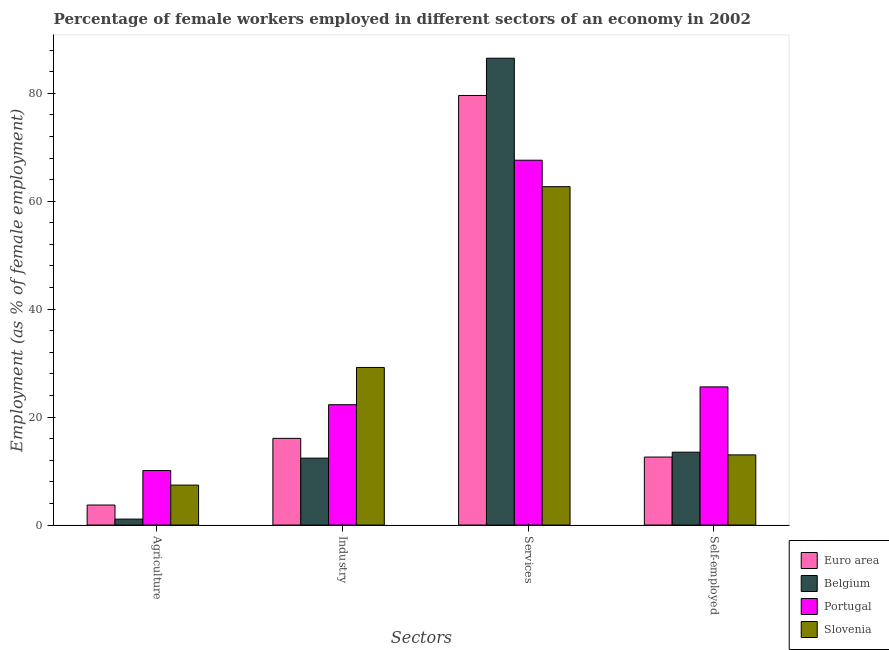How many groups of bars are there?
Keep it short and to the point. 4. What is the label of the 2nd group of bars from the left?
Provide a succinct answer. Industry. What is the percentage of female workers in agriculture in Belgium?
Give a very brief answer. 1.1. Across all countries, what is the maximum percentage of female workers in agriculture?
Your answer should be compact. 10.1. Across all countries, what is the minimum percentage of female workers in agriculture?
Your answer should be compact. 1.1. In which country was the percentage of female workers in industry maximum?
Your response must be concise. Slovenia. In which country was the percentage of female workers in services minimum?
Make the answer very short. Slovenia. What is the total percentage of female workers in services in the graph?
Offer a terse response. 296.4. What is the difference between the percentage of female workers in industry in Euro area and that in Slovenia?
Provide a short and direct response. -13.14. What is the difference between the percentage of female workers in agriculture in Portugal and the percentage of self employed female workers in Belgium?
Your response must be concise. -3.4. What is the average percentage of self employed female workers per country?
Make the answer very short. 16.17. What is the difference between the percentage of self employed female workers and percentage of female workers in industry in Belgium?
Keep it short and to the point. 1.1. In how many countries, is the percentage of female workers in agriculture greater than 44 %?
Keep it short and to the point. 0. What is the ratio of the percentage of self employed female workers in Euro area to that in Portugal?
Make the answer very short. 0.49. Is the percentage of female workers in agriculture in Slovenia less than that in Portugal?
Offer a very short reply. Yes. What is the difference between the highest and the second highest percentage of self employed female workers?
Give a very brief answer. 12.1. What is the difference between the highest and the lowest percentage of female workers in industry?
Give a very brief answer. 16.8. In how many countries, is the percentage of female workers in services greater than the average percentage of female workers in services taken over all countries?
Your answer should be compact. 2. Is the sum of the percentage of female workers in industry in Portugal and Euro area greater than the maximum percentage of female workers in agriculture across all countries?
Keep it short and to the point. Yes. Is it the case that in every country, the sum of the percentage of female workers in services and percentage of female workers in agriculture is greater than the sum of percentage of self employed female workers and percentage of female workers in industry?
Ensure brevity in your answer.  Yes. What does the 3rd bar from the right in Agriculture represents?
Give a very brief answer. Belgium. How many bars are there?
Provide a succinct answer. 16. Are all the bars in the graph horizontal?
Provide a succinct answer. No. What is the difference between two consecutive major ticks on the Y-axis?
Provide a succinct answer. 20. Are the values on the major ticks of Y-axis written in scientific E-notation?
Provide a succinct answer. No. Where does the legend appear in the graph?
Offer a terse response. Bottom right. How are the legend labels stacked?
Your response must be concise. Vertical. What is the title of the graph?
Your response must be concise. Percentage of female workers employed in different sectors of an economy in 2002. What is the label or title of the X-axis?
Ensure brevity in your answer.  Sectors. What is the label or title of the Y-axis?
Offer a very short reply. Employment (as % of female employment). What is the Employment (as % of female employment) in Euro area in Agriculture?
Make the answer very short. 3.71. What is the Employment (as % of female employment) of Belgium in Agriculture?
Your answer should be very brief. 1.1. What is the Employment (as % of female employment) in Portugal in Agriculture?
Keep it short and to the point. 10.1. What is the Employment (as % of female employment) in Slovenia in Agriculture?
Your answer should be very brief. 7.4. What is the Employment (as % of female employment) in Euro area in Industry?
Make the answer very short. 16.06. What is the Employment (as % of female employment) of Belgium in Industry?
Ensure brevity in your answer.  12.4. What is the Employment (as % of female employment) of Portugal in Industry?
Your answer should be compact. 22.3. What is the Employment (as % of female employment) of Slovenia in Industry?
Make the answer very short. 29.2. What is the Employment (as % of female employment) in Euro area in Services?
Provide a succinct answer. 79.6. What is the Employment (as % of female employment) in Belgium in Services?
Provide a succinct answer. 86.5. What is the Employment (as % of female employment) of Portugal in Services?
Provide a succinct answer. 67.6. What is the Employment (as % of female employment) of Slovenia in Services?
Offer a terse response. 62.7. What is the Employment (as % of female employment) of Euro area in Self-employed?
Provide a short and direct response. 12.6. What is the Employment (as % of female employment) of Portugal in Self-employed?
Offer a terse response. 25.6. What is the Employment (as % of female employment) in Slovenia in Self-employed?
Provide a short and direct response. 13. Across all Sectors, what is the maximum Employment (as % of female employment) of Euro area?
Offer a very short reply. 79.6. Across all Sectors, what is the maximum Employment (as % of female employment) in Belgium?
Provide a short and direct response. 86.5. Across all Sectors, what is the maximum Employment (as % of female employment) in Portugal?
Offer a terse response. 67.6. Across all Sectors, what is the maximum Employment (as % of female employment) of Slovenia?
Your answer should be compact. 62.7. Across all Sectors, what is the minimum Employment (as % of female employment) in Euro area?
Give a very brief answer. 3.71. Across all Sectors, what is the minimum Employment (as % of female employment) in Belgium?
Keep it short and to the point. 1.1. Across all Sectors, what is the minimum Employment (as % of female employment) in Portugal?
Ensure brevity in your answer.  10.1. Across all Sectors, what is the minimum Employment (as % of female employment) in Slovenia?
Your response must be concise. 7.4. What is the total Employment (as % of female employment) of Euro area in the graph?
Offer a terse response. 111.96. What is the total Employment (as % of female employment) in Belgium in the graph?
Give a very brief answer. 113.5. What is the total Employment (as % of female employment) in Portugal in the graph?
Ensure brevity in your answer.  125.6. What is the total Employment (as % of female employment) in Slovenia in the graph?
Your answer should be compact. 112.3. What is the difference between the Employment (as % of female employment) of Euro area in Agriculture and that in Industry?
Your answer should be compact. -12.35. What is the difference between the Employment (as % of female employment) of Belgium in Agriculture and that in Industry?
Provide a short and direct response. -11.3. What is the difference between the Employment (as % of female employment) in Slovenia in Agriculture and that in Industry?
Provide a succinct answer. -21.8. What is the difference between the Employment (as % of female employment) of Euro area in Agriculture and that in Services?
Ensure brevity in your answer.  -75.89. What is the difference between the Employment (as % of female employment) in Belgium in Agriculture and that in Services?
Give a very brief answer. -85.4. What is the difference between the Employment (as % of female employment) of Portugal in Agriculture and that in Services?
Provide a succinct answer. -57.5. What is the difference between the Employment (as % of female employment) of Slovenia in Agriculture and that in Services?
Offer a very short reply. -55.3. What is the difference between the Employment (as % of female employment) of Euro area in Agriculture and that in Self-employed?
Ensure brevity in your answer.  -8.89. What is the difference between the Employment (as % of female employment) in Belgium in Agriculture and that in Self-employed?
Keep it short and to the point. -12.4. What is the difference between the Employment (as % of female employment) of Portugal in Agriculture and that in Self-employed?
Keep it short and to the point. -15.5. What is the difference between the Employment (as % of female employment) of Slovenia in Agriculture and that in Self-employed?
Give a very brief answer. -5.6. What is the difference between the Employment (as % of female employment) in Euro area in Industry and that in Services?
Your answer should be very brief. -63.53. What is the difference between the Employment (as % of female employment) in Belgium in Industry and that in Services?
Offer a terse response. -74.1. What is the difference between the Employment (as % of female employment) of Portugal in Industry and that in Services?
Offer a terse response. -45.3. What is the difference between the Employment (as % of female employment) of Slovenia in Industry and that in Services?
Provide a short and direct response. -33.5. What is the difference between the Employment (as % of female employment) of Euro area in Industry and that in Self-employed?
Provide a succinct answer. 3.46. What is the difference between the Employment (as % of female employment) in Belgium in Industry and that in Self-employed?
Your answer should be compact. -1.1. What is the difference between the Employment (as % of female employment) of Portugal in Industry and that in Self-employed?
Your response must be concise. -3.3. What is the difference between the Employment (as % of female employment) in Euro area in Services and that in Self-employed?
Provide a succinct answer. 67. What is the difference between the Employment (as % of female employment) in Belgium in Services and that in Self-employed?
Your answer should be compact. 73. What is the difference between the Employment (as % of female employment) of Slovenia in Services and that in Self-employed?
Offer a terse response. 49.7. What is the difference between the Employment (as % of female employment) of Euro area in Agriculture and the Employment (as % of female employment) of Belgium in Industry?
Your answer should be compact. -8.69. What is the difference between the Employment (as % of female employment) in Euro area in Agriculture and the Employment (as % of female employment) in Portugal in Industry?
Give a very brief answer. -18.59. What is the difference between the Employment (as % of female employment) of Euro area in Agriculture and the Employment (as % of female employment) of Slovenia in Industry?
Keep it short and to the point. -25.49. What is the difference between the Employment (as % of female employment) in Belgium in Agriculture and the Employment (as % of female employment) in Portugal in Industry?
Your answer should be compact. -21.2. What is the difference between the Employment (as % of female employment) of Belgium in Agriculture and the Employment (as % of female employment) of Slovenia in Industry?
Provide a short and direct response. -28.1. What is the difference between the Employment (as % of female employment) in Portugal in Agriculture and the Employment (as % of female employment) in Slovenia in Industry?
Your response must be concise. -19.1. What is the difference between the Employment (as % of female employment) in Euro area in Agriculture and the Employment (as % of female employment) in Belgium in Services?
Offer a very short reply. -82.79. What is the difference between the Employment (as % of female employment) in Euro area in Agriculture and the Employment (as % of female employment) in Portugal in Services?
Your answer should be very brief. -63.89. What is the difference between the Employment (as % of female employment) in Euro area in Agriculture and the Employment (as % of female employment) in Slovenia in Services?
Your answer should be compact. -58.99. What is the difference between the Employment (as % of female employment) in Belgium in Agriculture and the Employment (as % of female employment) in Portugal in Services?
Offer a terse response. -66.5. What is the difference between the Employment (as % of female employment) in Belgium in Agriculture and the Employment (as % of female employment) in Slovenia in Services?
Offer a terse response. -61.6. What is the difference between the Employment (as % of female employment) of Portugal in Agriculture and the Employment (as % of female employment) of Slovenia in Services?
Your response must be concise. -52.6. What is the difference between the Employment (as % of female employment) in Euro area in Agriculture and the Employment (as % of female employment) in Belgium in Self-employed?
Make the answer very short. -9.79. What is the difference between the Employment (as % of female employment) of Euro area in Agriculture and the Employment (as % of female employment) of Portugal in Self-employed?
Give a very brief answer. -21.89. What is the difference between the Employment (as % of female employment) of Euro area in Agriculture and the Employment (as % of female employment) of Slovenia in Self-employed?
Make the answer very short. -9.29. What is the difference between the Employment (as % of female employment) of Belgium in Agriculture and the Employment (as % of female employment) of Portugal in Self-employed?
Give a very brief answer. -24.5. What is the difference between the Employment (as % of female employment) of Euro area in Industry and the Employment (as % of female employment) of Belgium in Services?
Your answer should be very brief. -70.44. What is the difference between the Employment (as % of female employment) of Euro area in Industry and the Employment (as % of female employment) of Portugal in Services?
Offer a terse response. -51.54. What is the difference between the Employment (as % of female employment) of Euro area in Industry and the Employment (as % of female employment) of Slovenia in Services?
Give a very brief answer. -46.64. What is the difference between the Employment (as % of female employment) of Belgium in Industry and the Employment (as % of female employment) of Portugal in Services?
Provide a succinct answer. -55.2. What is the difference between the Employment (as % of female employment) in Belgium in Industry and the Employment (as % of female employment) in Slovenia in Services?
Your answer should be compact. -50.3. What is the difference between the Employment (as % of female employment) of Portugal in Industry and the Employment (as % of female employment) of Slovenia in Services?
Provide a succinct answer. -40.4. What is the difference between the Employment (as % of female employment) in Euro area in Industry and the Employment (as % of female employment) in Belgium in Self-employed?
Ensure brevity in your answer.  2.56. What is the difference between the Employment (as % of female employment) in Euro area in Industry and the Employment (as % of female employment) in Portugal in Self-employed?
Your answer should be very brief. -9.54. What is the difference between the Employment (as % of female employment) of Euro area in Industry and the Employment (as % of female employment) of Slovenia in Self-employed?
Make the answer very short. 3.06. What is the difference between the Employment (as % of female employment) in Euro area in Services and the Employment (as % of female employment) in Belgium in Self-employed?
Keep it short and to the point. 66.1. What is the difference between the Employment (as % of female employment) in Euro area in Services and the Employment (as % of female employment) in Portugal in Self-employed?
Keep it short and to the point. 54. What is the difference between the Employment (as % of female employment) in Euro area in Services and the Employment (as % of female employment) in Slovenia in Self-employed?
Your answer should be compact. 66.6. What is the difference between the Employment (as % of female employment) in Belgium in Services and the Employment (as % of female employment) in Portugal in Self-employed?
Give a very brief answer. 60.9. What is the difference between the Employment (as % of female employment) in Belgium in Services and the Employment (as % of female employment) in Slovenia in Self-employed?
Offer a terse response. 73.5. What is the difference between the Employment (as % of female employment) in Portugal in Services and the Employment (as % of female employment) in Slovenia in Self-employed?
Provide a succinct answer. 54.6. What is the average Employment (as % of female employment) of Euro area per Sectors?
Keep it short and to the point. 27.99. What is the average Employment (as % of female employment) in Belgium per Sectors?
Make the answer very short. 28.38. What is the average Employment (as % of female employment) in Portugal per Sectors?
Give a very brief answer. 31.4. What is the average Employment (as % of female employment) in Slovenia per Sectors?
Your answer should be very brief. 28.07. What is the difference between the Employment (as % of female employment) in Euro area and Employment (as % of female employment) in Belgium in Agriculture?
Provide a succinct answer. 2.61. What is the difference between the Employment (as % of female employment) of Euro area and Employment (as % of female employment) of Portugal in Agriculture?
Offer a very short reply. -6.39. What is the difference between the Employment (as % of female employment) in Euro area and Employment (as % of female employment) in Slovenia in Agriculture?
Make the answer very short. -3.69. What is the difference between the Employment (as % of female employment) of Belgium and Employment (as % of female employment) of Portugal in Agriculture?
Provide a succinct answer. -9. What is the difference between the Employment (as % of female employment) of Portugal and Employment (as % of female employment) of Slovenia in Agriculture?
Provide a succinct answer. 2.7. What is the difference between the Employment (as % of female employment) in Euro area and Employment (as % of female employment) in Belgium in Industry?
Your answer should be very brief. 3.66. What is the difference between the Employment (as % of female employment) in Euro area and Employment (as % of female employment) in Portugal in Industry?
Provide a succinct answer. -6.24. What is the difference between the Employment (as % of female employment) of Euro area and Employment (as % of female employment) of Slovenia in Industry?
Give a very brief answer. -13.14. What is the difference between the Employment (as % of female employment) of Belgium and Employment (as % of female employment) of Portugal in Industry?
Make the answer very short. -9.9. What is the difference between the Employment (as % of female employment) in Belgium and Employment (as % of female employment) in Slovenia in Industry?
Provide a short and direct response. -16.8. What is the difference between the Employment (as % of female employment) in Portugal and Employment (as % of female employment) in Slovenia in Industry?
Ensure brevity in your answer.  -6.9. What is the difference between the Employment (as % of female employment) of Euro area and Employment (as % of female employment) of Belgium in Services?
Your answer should be compact. -6.9. What is the difference between the Employment (as % of female employment) in Euro area and Employment (as % of female employment) in Portugal in Services?
Provide a short and direct response. 12. What is the difference between the Employment (as % of female employment) in Euro area and Employment (as % of female employment) in Slovenia in Services?
Provide a short and direct response. 16.9. What is the difference between the Employment (as % of female employment) in Belgium and Employment (as % of female employment) in Portugal in Services?
Offer a very short reply. 18.9. What is the difference between the Employment (as % of female employment) of Belgium and Employment (as % of female employment) of Slovenia in Services?
Keep it short and to the point. 23.8. What is the difference between the Employment (as % of female employment) in Portugal and Employment (as % of female employment) in Slovenia in Services?
Provide a short and direct response. 4.9. What is the difference between the Employment (as % of female employment) in Euro area and Employment (as % of female employment) in Belgium in Self-employed?
Keep it short and to the point. -0.9. What is the difference between the Employment (as % of female employment) of Euro area and Employment (as % of female employment) of Portugal in Self-employed?
Make the answer very short. -13. What is the difference between the Employment (as % of female employment) in Euro area and Employment (as % of female employment) in Slovenia in Self-employed?
Keep it short and to the point. -0.4. What is the difference between the Employment (as % of female employment) in Belgium and Employment (as % of female employment) in Slovenia in Self-employed?
Give a very brief answer. 0.5. What is the ratio of the Employment (as % of female employment) of Euro area in Agriculture to that in Industry?
Ensure brevity in your answer.  0.23. What is the ratio of the Employment (as % of female employment) in Belgium in Agriculture to that in Industry?
Your answer should be compact. 0.09. What is the ratio of the Employment (as % of female employment) in Portugal in Agriculture to that in Industry?
Keep it short and to the point. 0.45. What is the ratio of the Employment (as % of female employment) of Slovenia in Agriculture to that in Industry?
Provide a short and direct response. 0.25. What is the ratio of the Employment (as % of female employment) of Euro area in Agriculture to that in Services?
Your answer should be very brief. 0.05. What is the ratio of the Employment (as % of female employment) in Belgium in Agriculture to that in Services?
Keep it short and to the point. 0.01. What is the ratio of the Employment (as % of female employment) in Portugal in Agriculture to that in Services?
Your answer should be very brief. 0.15. What is the ratio of the Employment (as % of female employment) of Slovenia in Agriculture to that in Services?
Your answer should be compact. 0.12. What is the ratio of the Employment (as % of female employment) in Euro area in Agriculture to that in Self-employed?
Your answer should be compact. 0.29. What is the ratio of the Employment (as % of female employment) of Belgium in Agriculture to that in Self-employed?
Your answer should be compact. 0.08. What is the ratio of the Employment (as % of female employment) of Portugal in Agriculture to that in Self-employed?
Give a very brief answer. 0.39. What is the ratio of the Employment (as % of female employment) in Slovenia in Agriculture to that in Self-employed?
Keep it short and to the point. 0.57. What is the ratio of the Employment (as % of female employment) of Euro area in Industry to that in Services?
Give a very brief answer. 0.2. What is the ratio of the Employment (as % of female employment) of Belgium in Industry to that in Services?
Your response must be concise. 0.14. What is the ratio of the Employment (as % of female employment) of Portugal in Industry to that in Services?
Provide a short and direct response. 0.33. What is the ratio of the Employment (as % of female employment) in Slovenia in Industry to that in Services?
Give a very brief answer. 0.47. What is the ratio of the Employment (as % of female employment) of Euro area in Industry to that in Self-employed?
Your answer should be compact. 1.27. What is the ratio of the Employment (as % of female employment) of Belgium in Industry to that in Self-employed?
Your answer should be compact. 0.92. What is the ratio of the Employment (as % of female employment) of Portugal in Industry to that in Self-employed?
Ensure brevity in your answer.  0.87. What is the ratio of the Employment (as % of female employment) in Slovenia in Industry to that in Self-employed?
Your response must be concise. 2.25. What is the ratio of the Employment (as % of female employment) of Euro area in Services to that in Self-employed?
Give a very brief answer. 6.32. What is the ratio of the Employment (as % of female employment) in Belgium in Services to that in Self-employed?
Give a very brief answer. 6.41. What is the ratio of the Employment (as % of female employment) in Portugal in Services to that in Self-employed?
Provide a short and direct response. 2.64. What is the ratio of the Employment (as % of female employment) in Slovenia in Services to that in Self-employed?
Provide a succinct answer. 4.82. What is the difference between the highest and the second highest Employment (as % of female employment) of Euro area?
Give a very brief answer. 63.53. What is the difference between the highest and the second highest Employment (as % of female employment) of Belgium?
Provide a short and direct response. 73. What is the difference between the highest and the second highest Employment (as % of female employment) in Portugal?
Offer a terse response. 42. What is the difference between the highest and the second highest Employment (as % of female employment) of Slovenia?
Give a very brief answer. 33.5. What is the difference between the highest and the lowest Employment (as % of female employment) of Euro area?
Your response must be concise. 75.89. What is the difference between the highest and the lowest Employment (as % of female employment) in Belgium?
Give a very brief answer. 85.4. What is the difference between the highest and the lowest Employment (as % of female employment) in Portugal?
Provide a short and direct response. 57.5. What is the difference between the highest and the lowest Employment (as % of female employment) in Slovenia?
Provide a succinct answer. 55.3. 